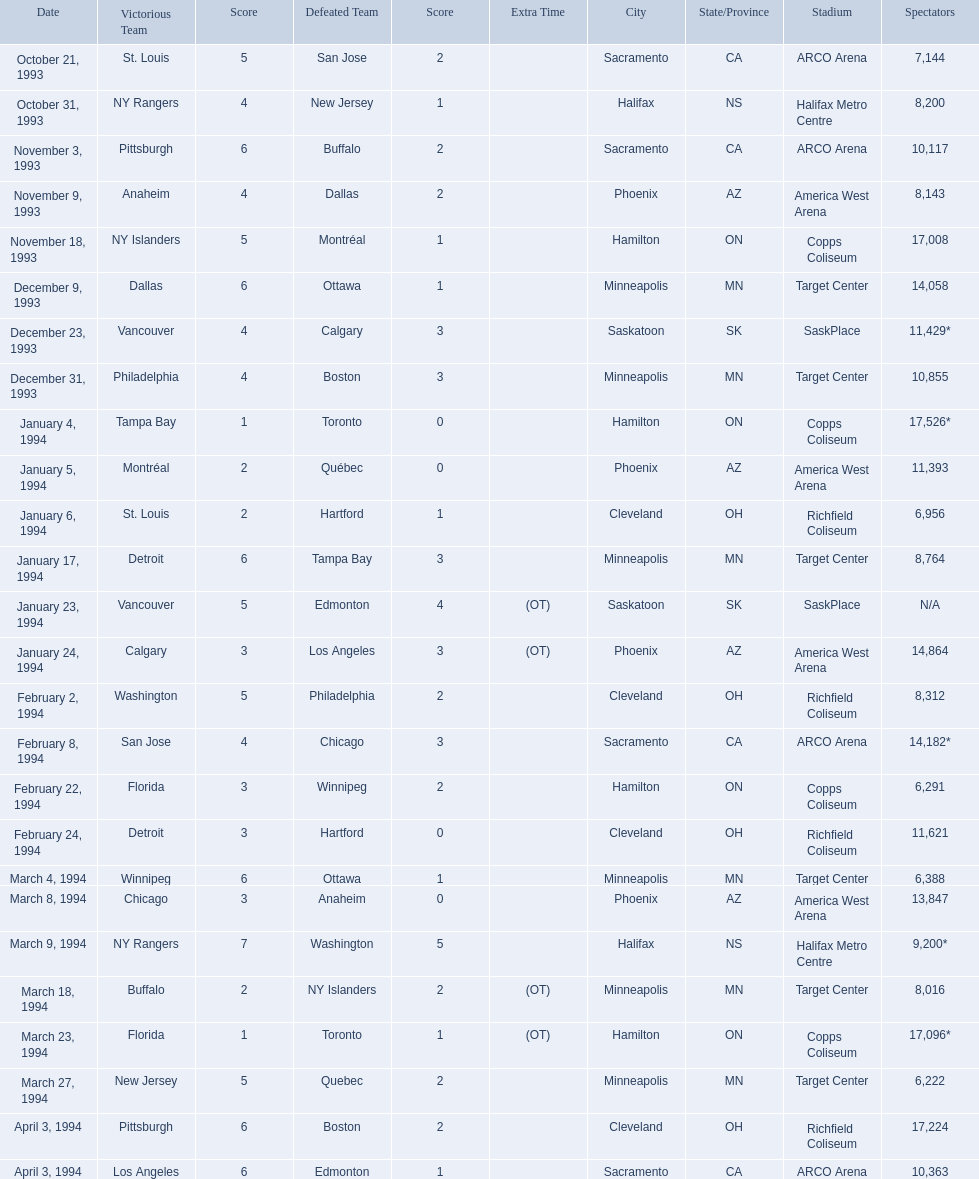Which dates saw the winning team score only one point? January 4, 1994, March 23, 1994. Of these two, which date had higher attendance? January 4, 1994. 